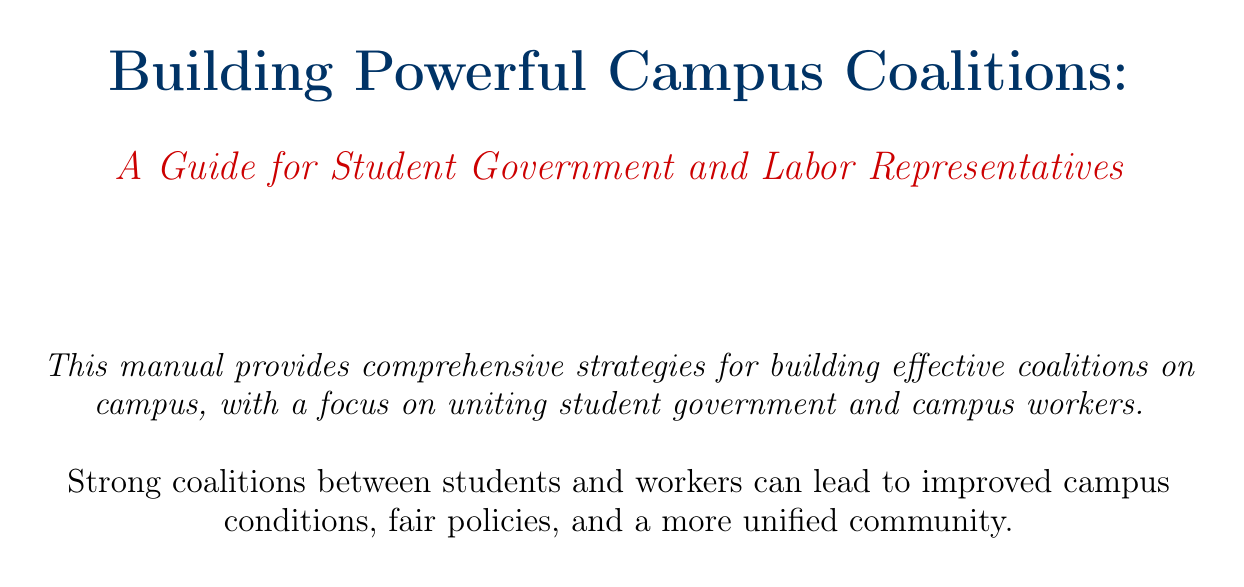what is the manual title? The title of the manual is the first item presented in the document and is "Building Powerful Campus Coalitions: A Guide for Student Government and Labor Representatives."
Answer: Building Powerful Campus Coalitions: A Guide for Student Government and Labor Representatives what is the focus of the manual? The overview section outlines that the manual focuses on uniting student government and campus workers.
Answer: Uniting student government and campus workers who are mentioned as key stakeholders on campus? The document lists important groups as key stakeholders, including the Student Government Association and various labor unions.
Answer: Student Government Association, various labor unions what strategy is suggested for creating common ground? The section on creating common ground mentions identifying shared interests as the strategy.
Answer: Identifying shared interests which coalition is analyzed as a case study? The document contains a case study analysis of the University of California System-Wide Coalition campaign that advocated for fair wages.
Answer: University of California System-Wide Coalition what is one potential pitfall to avoid while building coalitions? The best practices section includes avoiding tokenism as a critical pitfall to watch for in coalitions.
Answer: Avoiding tokenism what tool is recommended for internal communication? The resources section offers several tools, naming Slack specifically for internal communication among coalition members.
Answer: Slack how many chapters are in the manual? The table of contents indicates that there are eight chapters in the manual.
Answer: Eight 